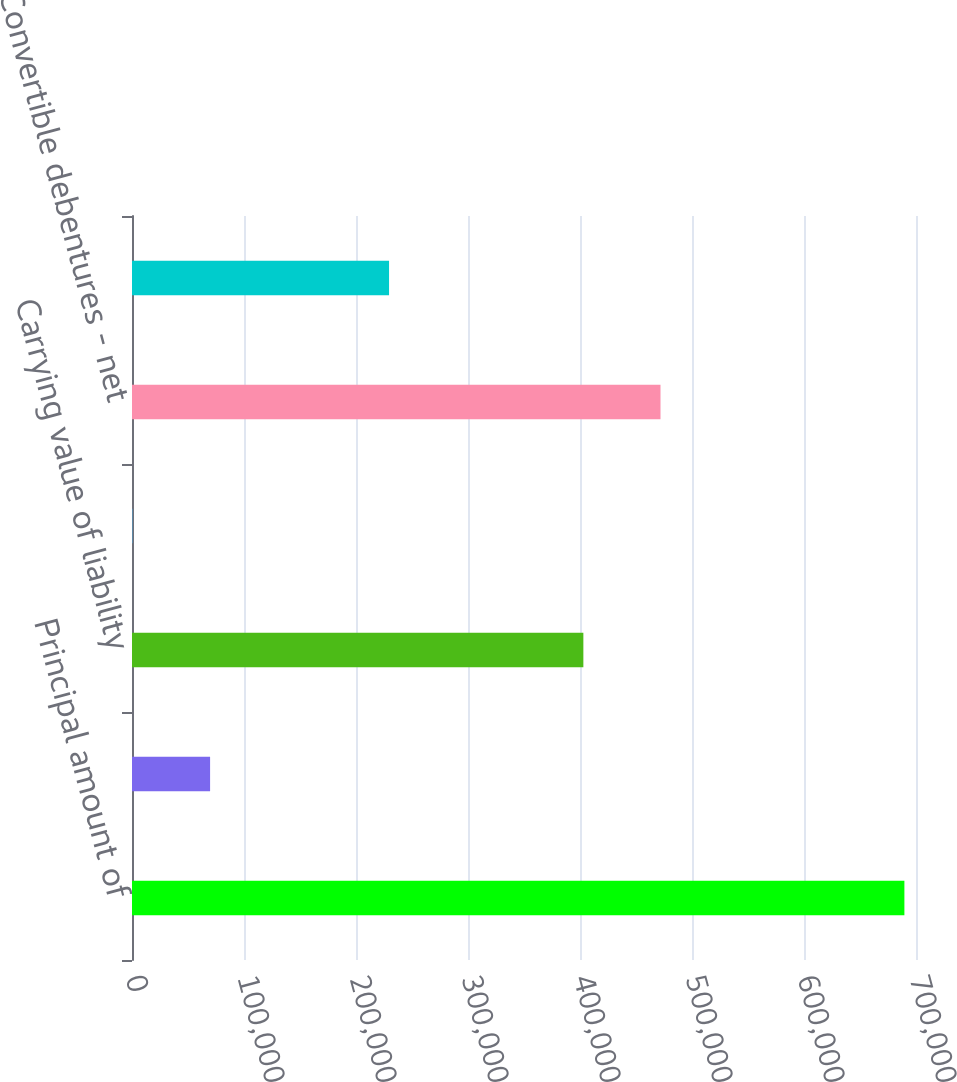Convert chart to OTSL. <chart><loc_0><loc_0><loc_500><loc_500><bar_chart><fcel>Principal amount of<fcel>Unamortized discount of<fcel>Carrying value of liability<fcel>Carrying value of embedded<fcel>Convertible debentures - net<fcel>Equity component - net<nl><fcel>689635<fcel>69726.7<fcel>403002<fcel>848<fcel>471880<fcel>229513<nl></chart> 